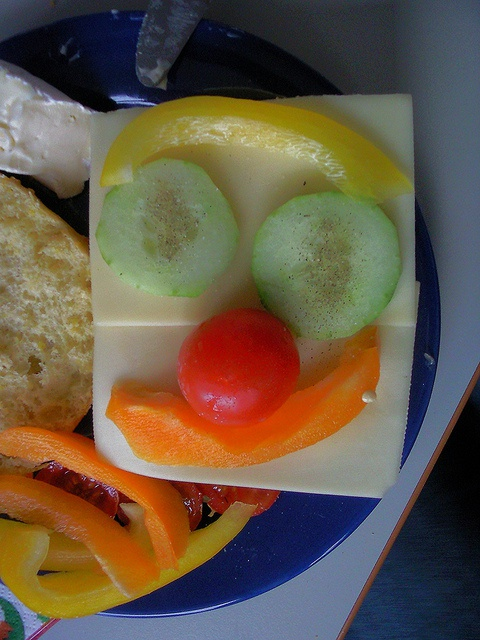Describe the objects in this image and their specific colors. I can see dining table in black, gray, olive, and blue tones, dining table in blue, black, navy, maroon, and darkblue tones, and knife in blue, black, and gray tones in this image. 